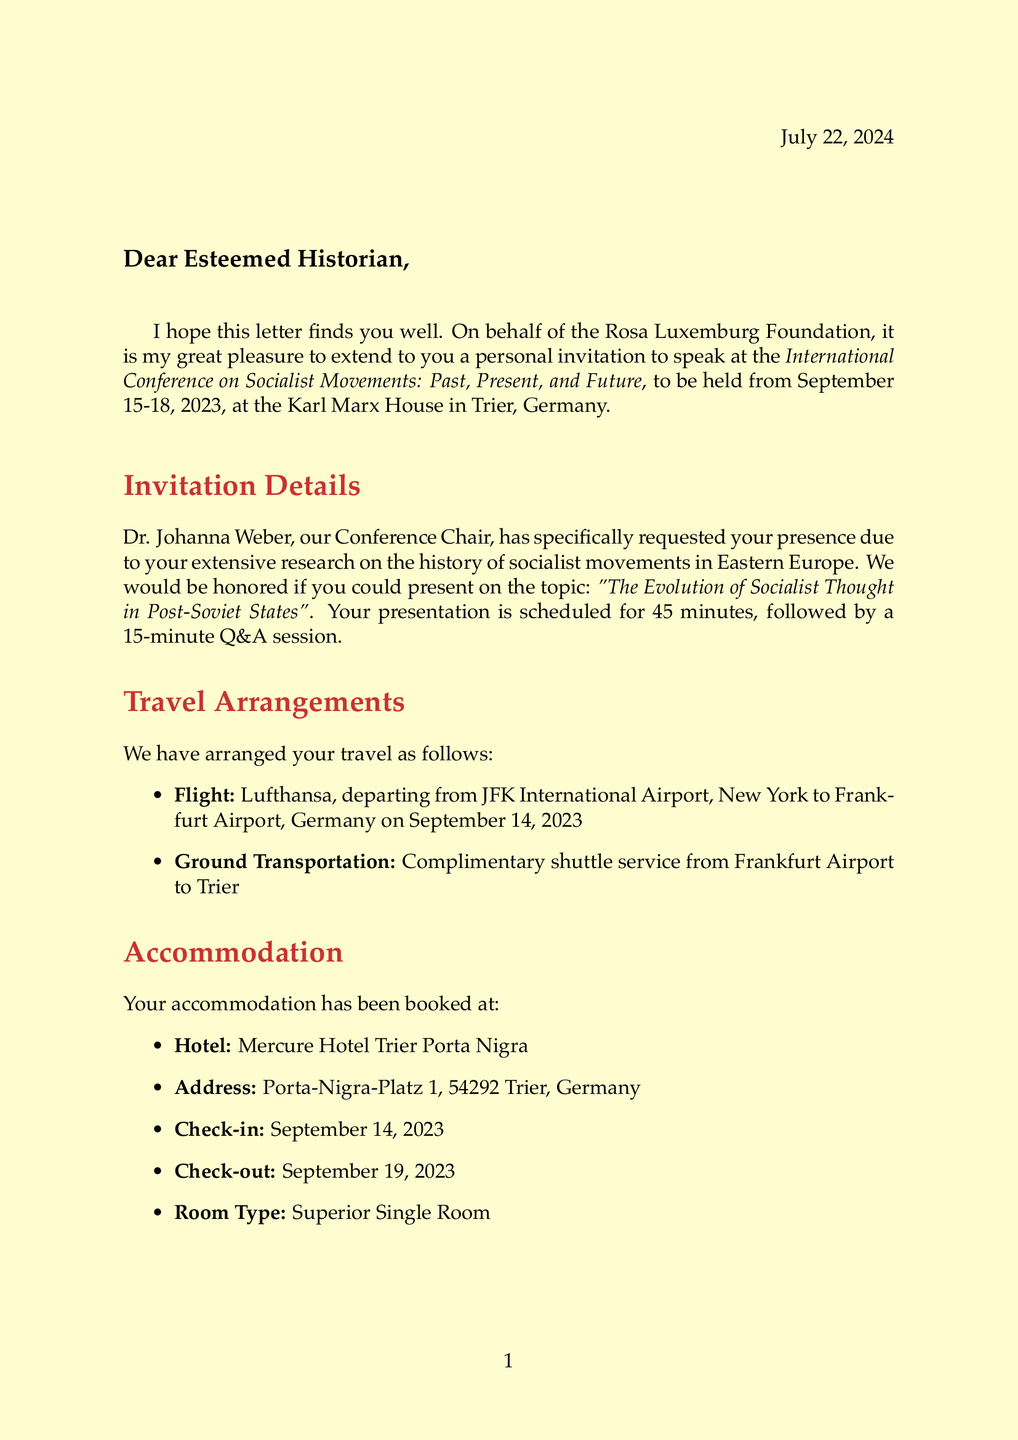What is the name of the conference? The document specifies the title of the conference as "International Conference on Socialist Movements: Past, Present, and Future."
Answer: International Conference on Socialist Movements: Past, Present, and Future Who invited the historian to speak? The invitation in the document identifies Dr. Johanna Weber as the person who invited the historian.
Answer: Dr. Johanna Weber What is the suggested presentation topic? The document includes the suggested presentation topic as "The Evolution of Socialist Thought in Post-Soviet States."
Answer: The Evolution of Socialist Thought in Post-Soviet States What airline is arranged for travel? The flight information indicates that Lufthansa is the airline booked for the historian's travel to the conference.
Answer: Lufthansa What is the check-in date for the accommodation? The document lists the check-in date for the accommodation as September 14, 2023.
Answer: September 14, 2023 What honorarium is offered? The document states that the honorarium provided to the historian is €500.
Answer: €500 What language will the conference be conducted in? The additional information in the document specifies that the conference language is English.
Answer: English How long is the presentation session? The invitation details mention the presentation duration is 45 minutes followed by a 15-minute Q&A.
Answer: 45 minutes What is the dress code for the conference? The document indicates that the dress code for the conference is business casual.
Answer: Business casual 